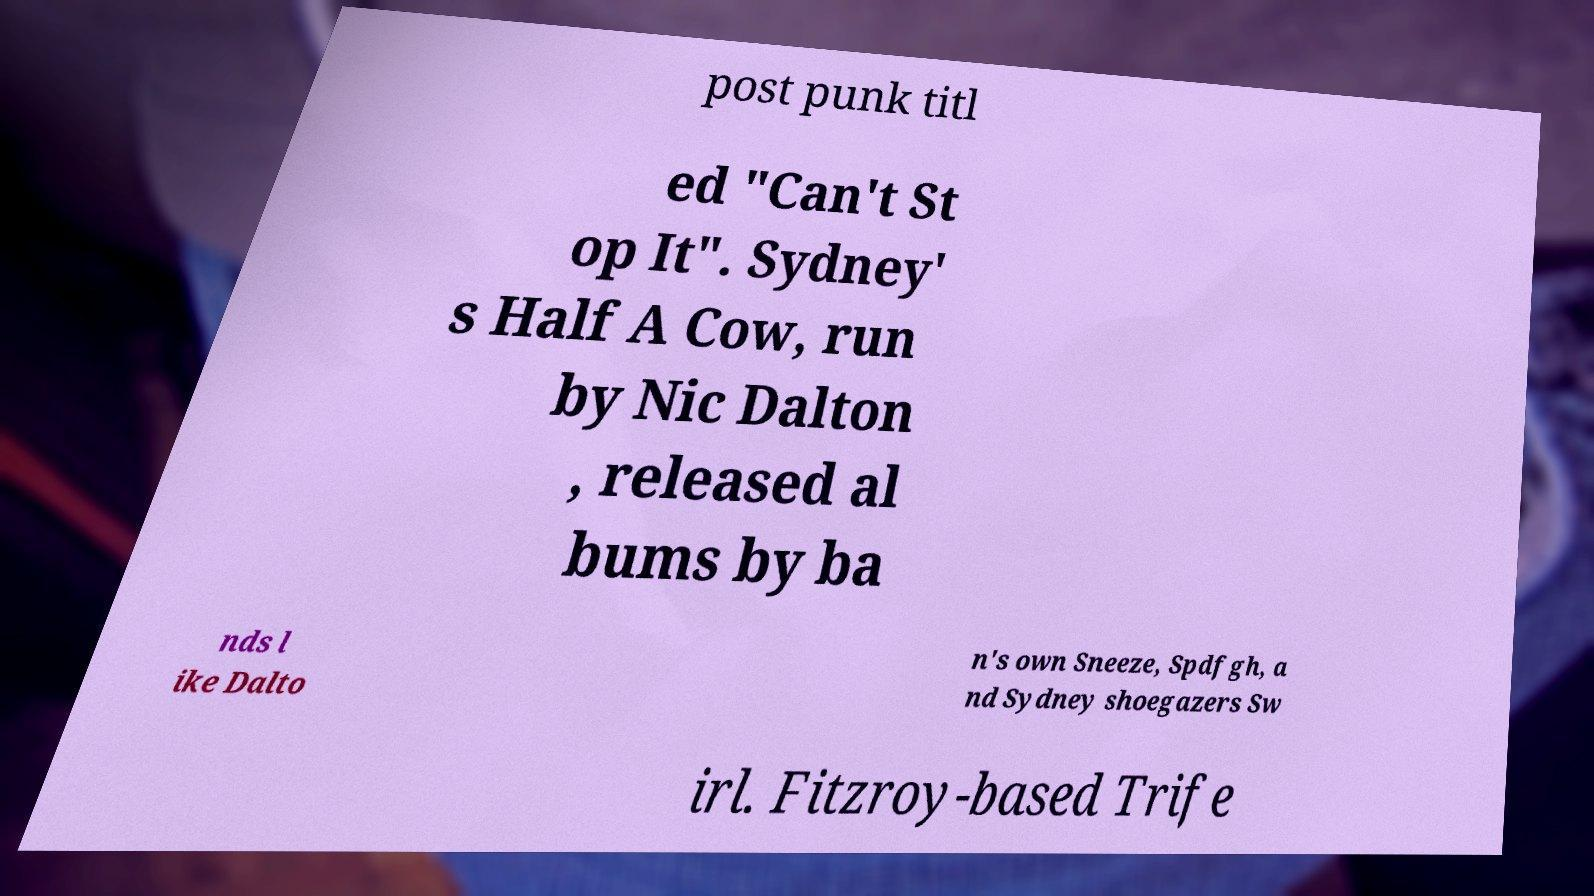What messages or text are displayed in this image? I need them in a readable, typed format. post punk titl ed "Can't St op It". Sydney' s Half A Cow, run by Nic Dalton , released al bums by ba nds l ike Dalto n's own Sneeze, Spdfgh, a nd Sydney shoegazers Sw irl. Fitzroy-based Trife 